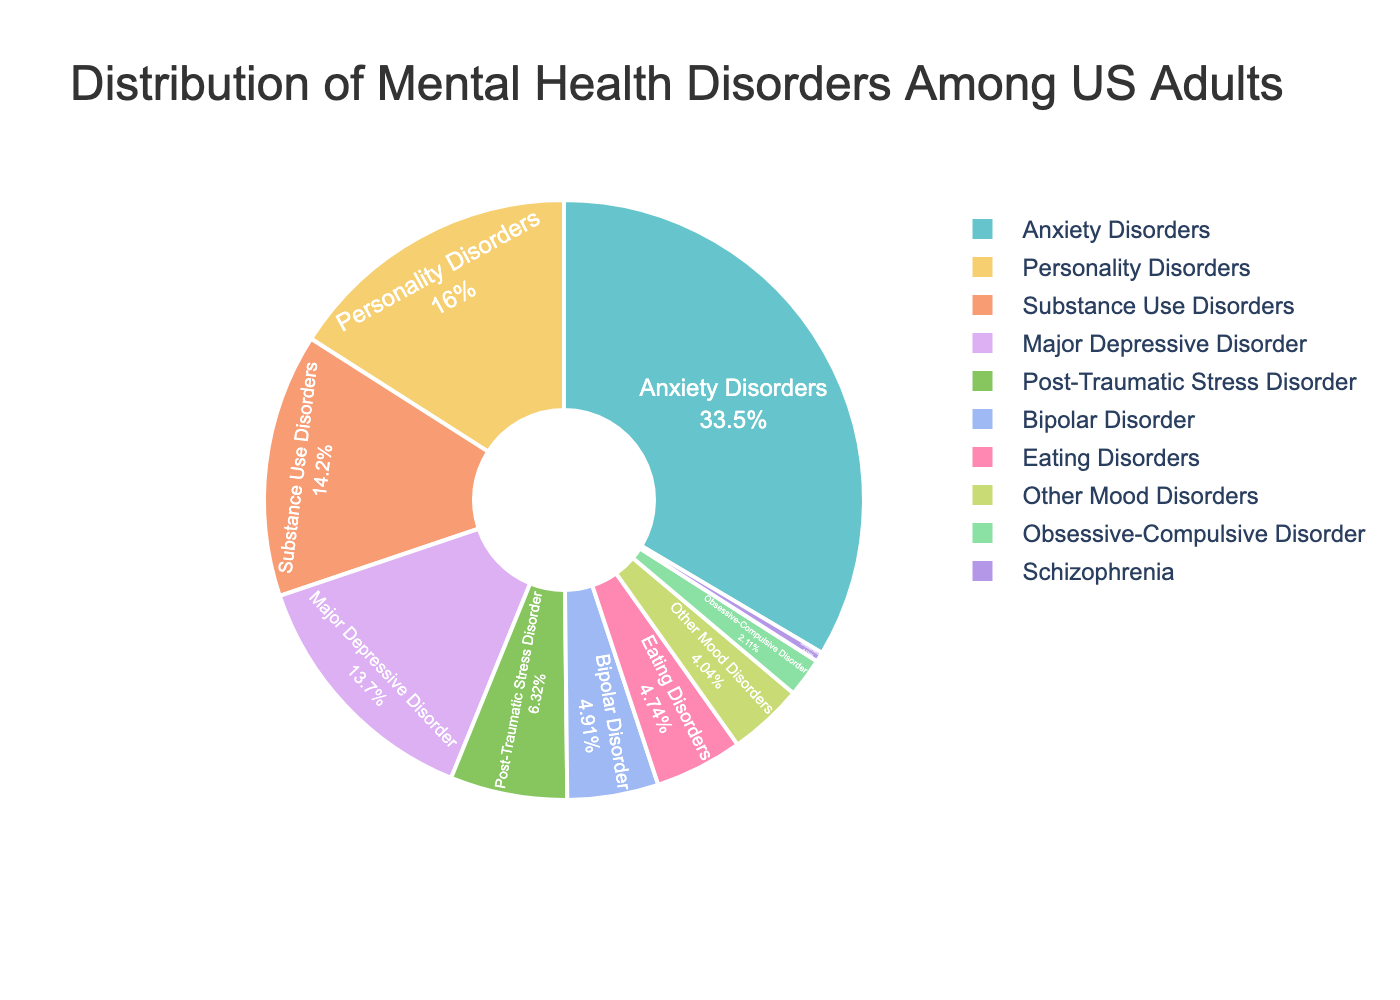What percentage of adults suffer from Anxiety Disorders? Anxiety Disorders occupy the largest segment of the pie chart. The segment has a text label showing the exact percentage, which is 19.1%.
Answer: 19.1% Which disorders collectively account for more than 30% prevalence? Adding the prevalence of Anxiety Disorders (19.1%), Major Depressive Disorder (7.8%), and Substance Use Disorders (8.1%) gives a total of 35%, which is more than 30%.
Answer: Anxiety Disorders, Major Depressive Disorder, Substance Use Disorders Which disorder has the smallest prevalence? By looking at the pie chart, the smallest segment represents Schizophrenia, with a prevalence of 0.3%.
Answer: Schizophrenia Is the prevalence of Bipolar Disorder greater than Eating Disorders? Comparing the segments for Bipolar Disorder (2.8%) and Eating Disorders (2.7%), Bipolar Disorder has a slightly higher prevalence.
Answer: Yes What is the combined prevalence of Major Depressive Disorder and Personality Disorders? Adding the prevalence rates of Major Depressive Disorder (7.8%) and Personality Disorders (9.1%) gives a total of 16.9%.
Answer: 16.9% Which disorder represents a percentage close to 10%? The segment for Personality Disorders represents 9.1%, which is closest to 10%.
Answer: Personality Disorders Is the total prevalence of disorders other than Anxiety Disorders and Substance Use Disorders more or less than 50%? Subtracting the prevalence of Anxiety Disorders (19.1%) and Substance Use Disorders (8.1%) from 100% results in 72.8%, which is more than 50%.
Answer: More How does the prevalence of Major Depressive Disorder compare to Substance Use Disorders? The pie chart shows Major Depressive Disorder at 7.8% and Substance Use Disorders at 8.1%. Major Depressive Disorder has a slightly lower prevalence compared to Substance Use Disorders.
Answer: Lower What is the difference in prevalence between Post-Traumatic Stress Disorder and Bipolar Disorder? Subtracting the prevalence of Bipolar Disorder (2.8%) from Post-Traumatic Stress Disorder (3.6%) results in a difference of 0.8%.
Answer: 0.8% Which disorders have a prevalence between 2% and 5%? By observing the pie chart, the disorders that fall within the 2%-5% range are Post-Traumatic Stress Disorder (3.6%), Bipolar Disorder (2.8%), Eating Disorders (2.7%), and Other Mood Disorders (2.3%).
Answer: Post-Traumatic Stress Disorder, Bipolar Disorder, Eating Disorders, Other Mood Disorders 